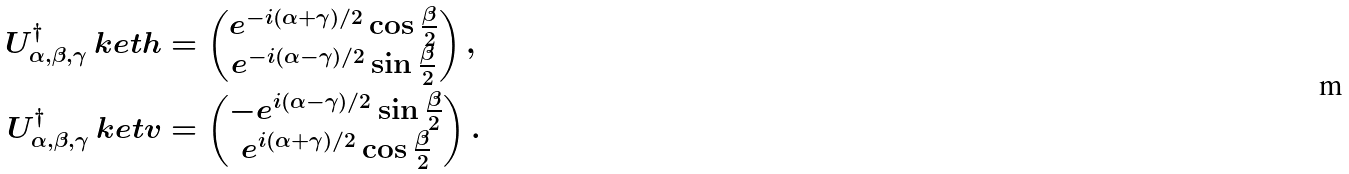<formula> <loc_0><loc_0><loc_500><loc_500>U ^ { \dagger } _ { \alpha , \beta , \gamma } \ k e t { h } & = \begin{pmatrix} e ^ { - i ( \alpha + \gamma ) / 2 } \cos \frac { \beta } { 2 } \\ e ^ { - i ( \alpha - \gamma ) / 2 } \sin \frac { \beta } { 2 } \end{pmatrix} , \\ U ^ { \dagger } _ { \alpha , \beta , \gamma } \ k e t { v } & = \begin{pmatrix} - e ^ { i ( \alpha - \gamma ) / 2 } \sin \frac { \beta } { 2 } \\ e ^ { i ( \alpha + \gamma ) / 2 } \cos \frac { \beta } { 2 } \end{pmatrix} .</formula> 